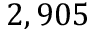<formula> <loc_0><loc_0><loc_500><loc_500>2 , 9 0 5</formula> 